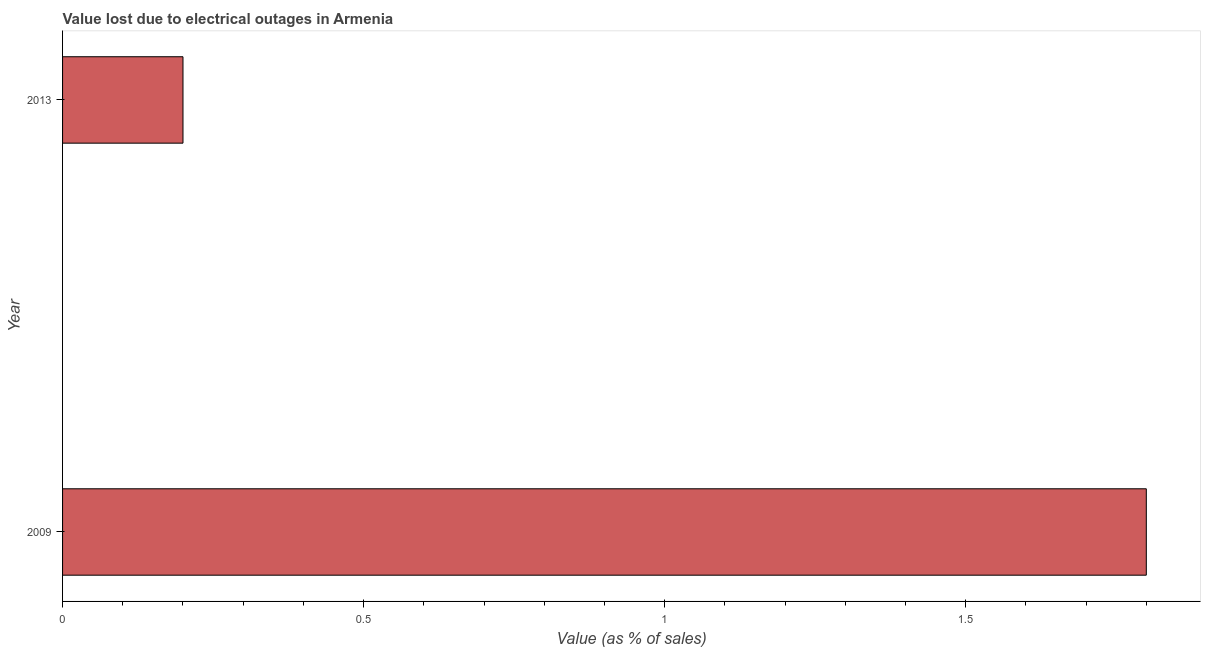Does the graph contain any zero values?
Offer a very short reply. No. Does the graph contain grids?
Give a very brief answer. No. What is the title of the graph?
Offer a very short reply. Value lost due to electrical outages in Armenia. What is the label or title of the X-axis?
Provide a short and direct response. Value (as % of sales). Across all years, what is the maximum value lost due to electrical outages?
Offer a very short reply. 1.8. In which year was the value lost due to electrical outages minimum?
Provide a short and direct response. 2013. What is the sum of the value lost due to electrical outages?
Ensure brevity in your answer.  2. What is the difference between the value lost due to electrical outages in 2009 and 2013?
Your answer should be compact. 1.6. In how many years, is the value lost due to electrical outages greater than 1.7 %?
Offer a very short reply. 1. What is the ratio of the value lost due to electrical outages in 2009 to that in 2013?
Your response must be concise. 9. Are all the bars in the graph horizontal?
Offer a terse response. Yes. How many years are there in the graph?
Give a very brief answer. 2. What is the difference between the Value (as % of sales) in 2009 and 2013?
Your answer should be compact. 1.6. What is the ratio of the Value (as % of sales) in 2009 to that in 2013?
Your answer should be compact. 9. 